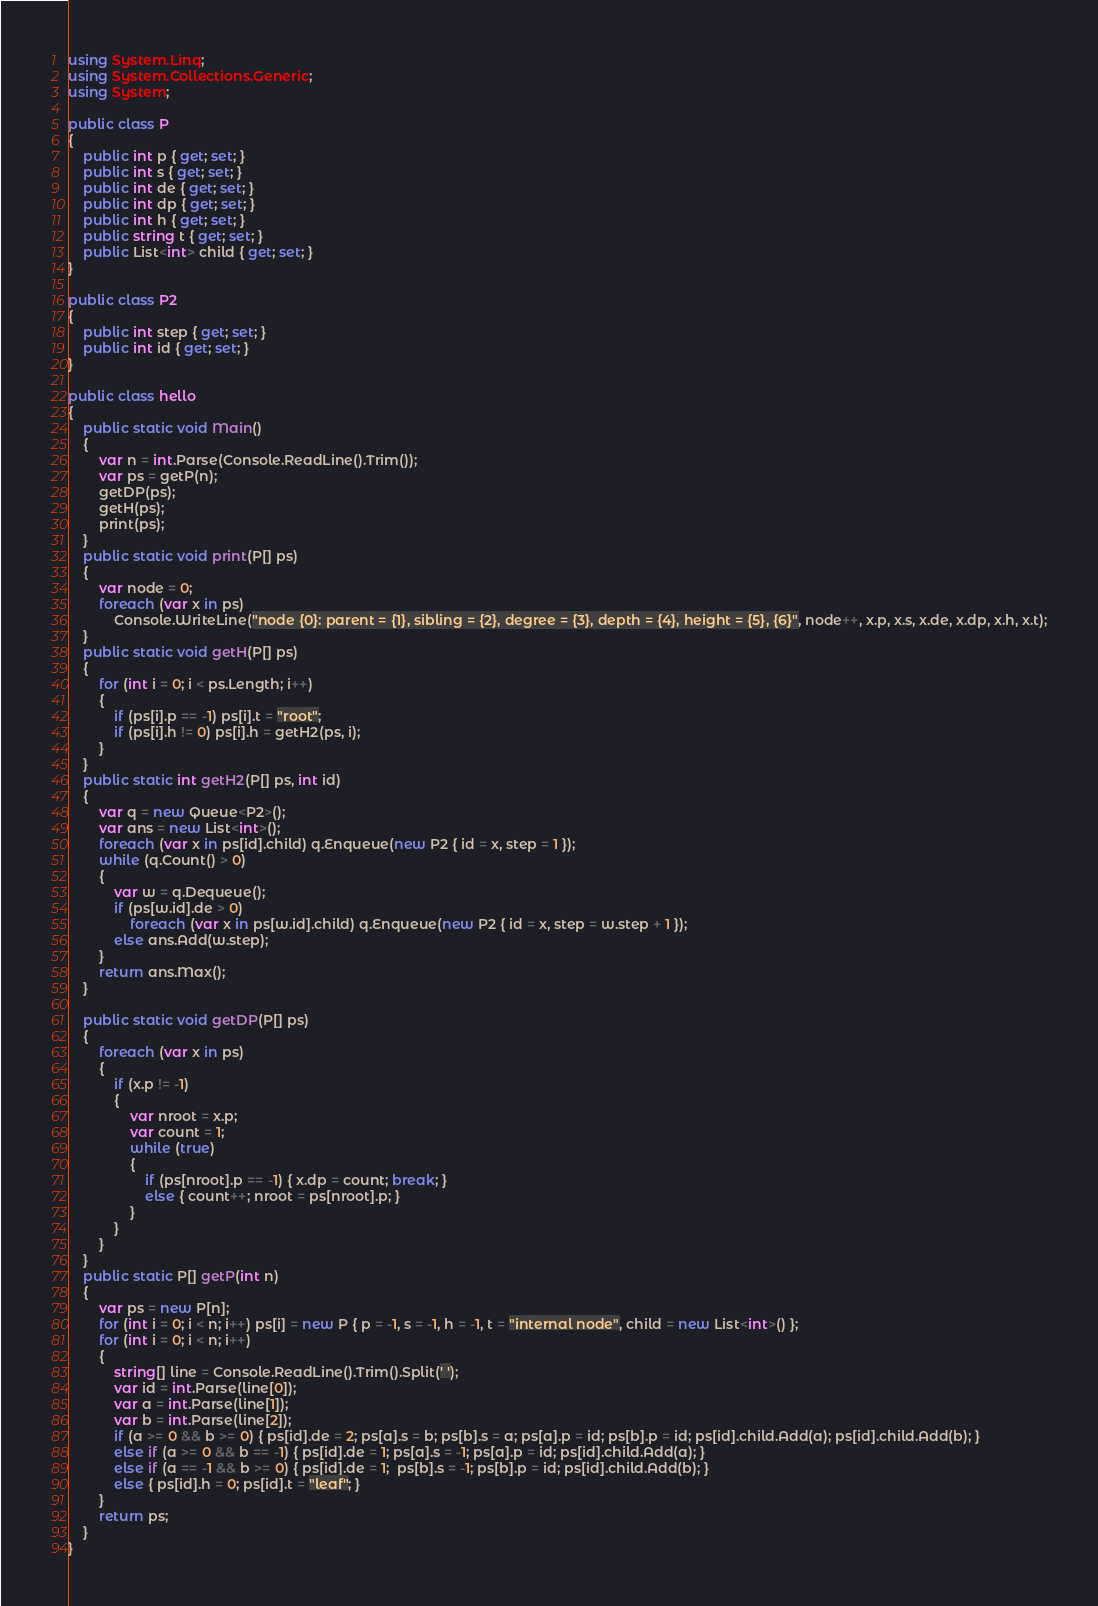Convert code to text. <code><loc_0><loc_0><loc_500><loc_500><_C#_>using System.Linq;
using System.Collections.Generic;
using System;

public class P
{
    public int p { get; set; }
    public int s { get; set; }
    public int de { get; set; }
    public int dp { get; set; }
    public int h { get; set; }
    public string t { get; set; }
    public List<int> child { get; set; }
}

public class P2
{
    public int step { get; set; }
    public int id { get; set; }
}

public class hello
{
    public static void Main()
    {
        var n = int.Parse(Console.ReadLine().Trim());
        var ps = getP(n);
        getDP(ps);
        getH(ps);
        print(ps);
    }
    public static void print(P[] ps)
    {
        var node = 0;
        foreach (var x in ps)
            Console.WriteLine("node {0}: parent = {1}, sibling = {2}, degree = {3}, depth = {4}, height = {5}, {6}", node++, x.p, x.s, x.de, x.dp, x.h, x.t);
    }
    public static void getH(P[] ps)
    {
        for (int i = 0; i < ps.Length; i++)
        {
            if (ps[i].p == -1) ps[i].t = "root";
            if (ps[i].h != 0) ps[i].h = getH2(ps, i);
        }
    }
    public static int getH2(P[] ps, int id)
    {
        var q = new Queue<P2>();
        var ans = new List<int>();
        foreach (var x in ps[id].child) q.Enqueue(new P2 { id = x, step = 1 });
        while (q.Count() > 0)
        {
            var w = q.Dequeue();
            if (ps[w.id].de > 0)
                foreach (var x in ps[w.id].child) q.Enqueue(new P2 { id = x, step = w.step + 1 });
            else ans.Add(w.step);
        }
        return ans.Max();
    }

    public static void getDP(P[] ps)
    {
        foreach (var x in ps)
        {
            if (x.p != -1)
            {
                var nroot = x.p;
                var count = 1;
                while (true)
                {
                    if (ps[nroot].p == -1) { x.dp = count; break; }
                    else { count++; nroot = ps[nroot].p; }
                }
            }
        }
    }
    public static P[] getP(int n)
    {
        var ps = new P[n];
        for (int i = 0; i < n; i++) ps[i] = new P { p = -1, s = -1, h = -1, t = "internal node", child = new List<int>() };
        for (int i = 0; i < n; i++)
        {
            string[] line = Console.ReadLine().Trim().Split(' ');
            var id = int.Parse(line[0]);
            var a = int.Parse(line[1]);
            var b = int.Parse(line[2]);
            if (a >= 0 && b >= 0) { ps[id].de = 2; ps[a].s = b; ps[b].s = a; ps[a].p = id; ps[b].p = id; ps[id].child.Add(a); ps[id].child.Add(b); }
            else if (a >= 0 && b == -1) { ps[id].de = 1; ps[a].s = -1; ps[a].p = id; ps[id].child.Add(a); }
            else if (a == -1 && b >= 0) { ps[id].de = 1;  ps[b].s = -1; ps[b].p = id; ps[id].child.Add(b); }
            else { ps[id].h = 0; ps[id].t = "leaf"; }
        }
        return ps;
    }
}
</code> 